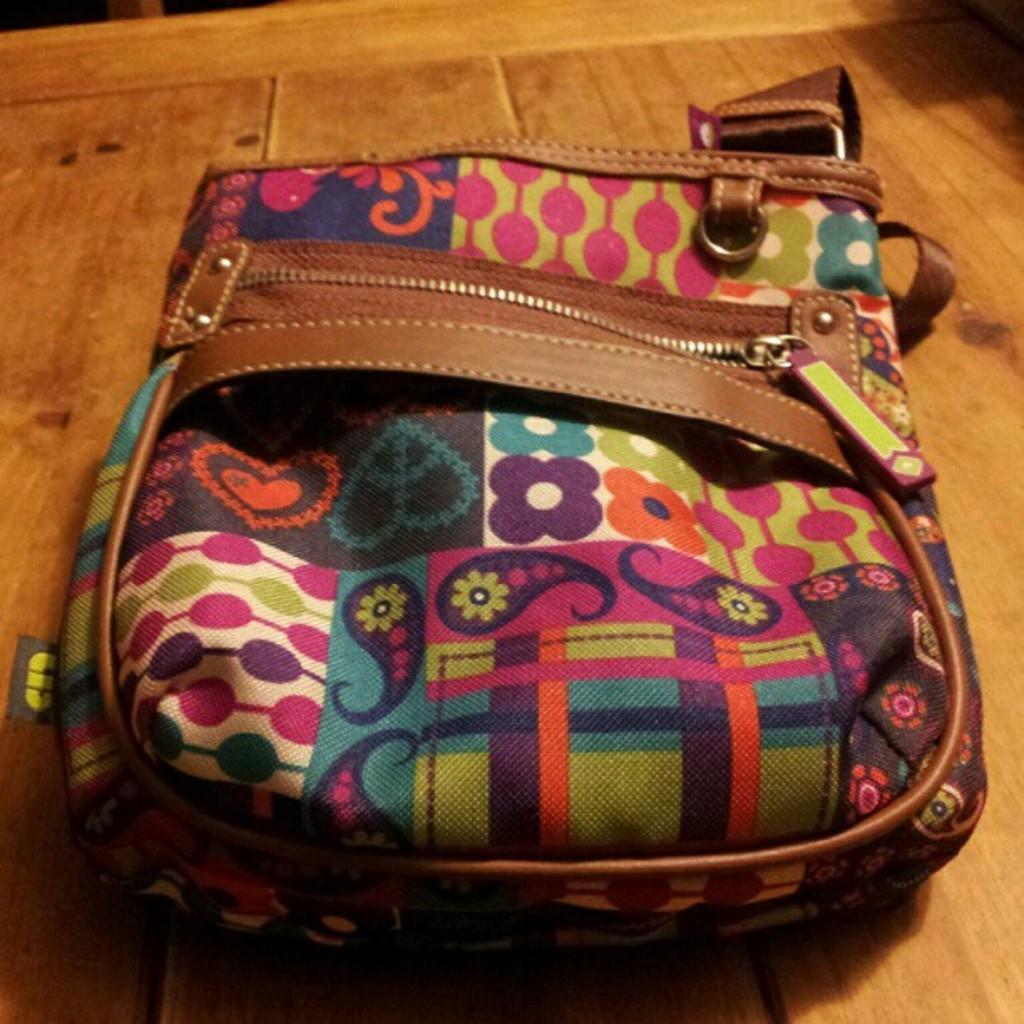Can you describe this image briefly? In the picture, there is a bag which is of multi color and lot of arts on this bag, there is single zip, there is a chain to hold the bag it is placed on the brown color table. 